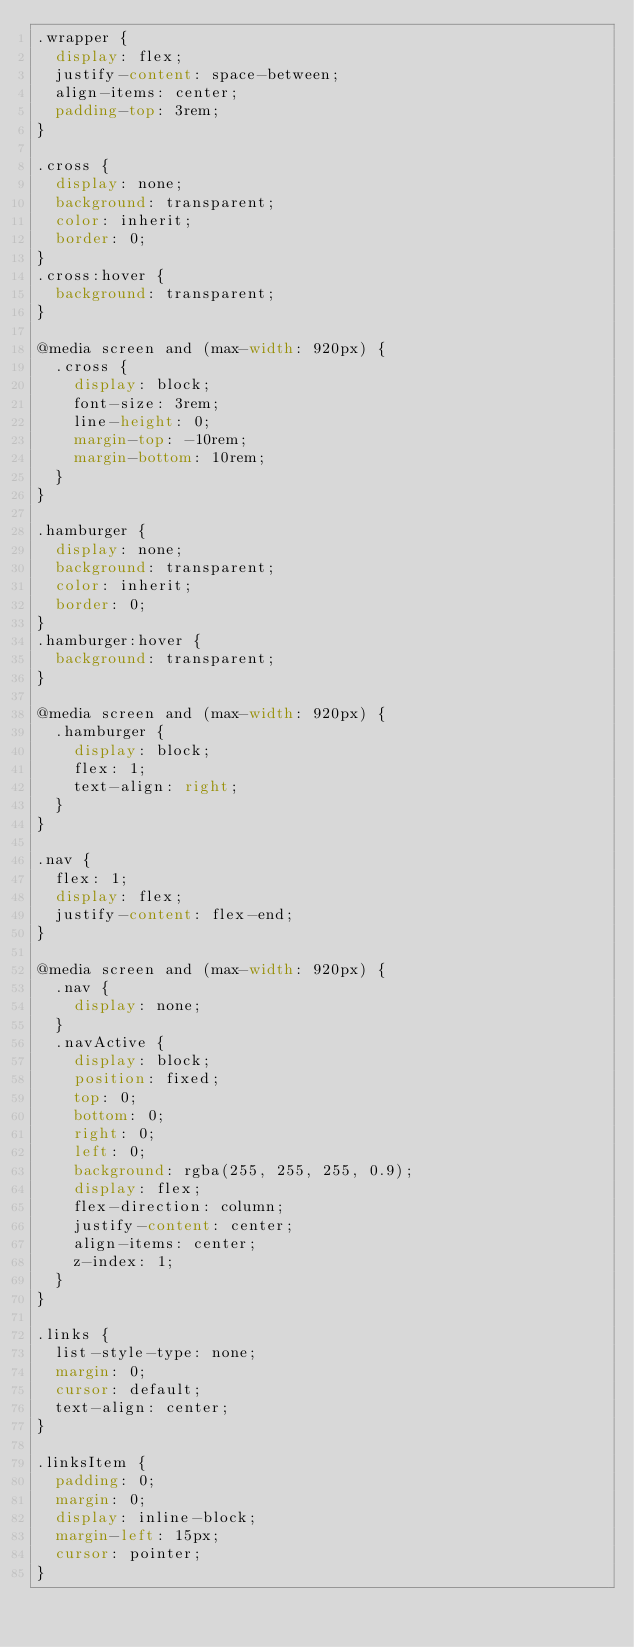Convert code to text. <code><loc_0><loc_0><loc_500><loc_500><_CSS_>.wrapper {
  display: flex;
  justify-content: space-between;
  align-items: center;
  padding-top: 3rem;
}

.cross {
  display: none;
  background: transparent;
  color: inherit;
  border: 0;
}
.cross:hover {
  background: transparent;
}

@media screen and (max-width: 920px) {
  .cross {
    display: block;
    font-size: 3rem;
    line-height: 0;
    margin-top: -10rem;
    margin-bottom: 10rem;
  }
}

.hamburger {
  display: none;
  background: transparent;
  color: inherit;
  border: 0;
}
.hamburger:hover {
  background: transparent;
}

@media screen and (max-width: 920px) {
  .hamburger {
    display: block;
    flex: 1;
    text-align: right;
  }
}

.nav {
  flex: 1;
  display: flex;
  justify-content: flex-end;
}

@media screen and (max-width: 920px) {
  .nav {
    display: none;
  }
  .navActive {
    display: block;
    position: fixed;
    top: 0;
    bottom: 0;
    right: 0;
    left: 0;
    background: rgba(255, 255, 255, 0.9);
    display: flex;
    flex-direction: column;
    justify-content: center;
    align-items: center;
    z-index: 1;
  }
}

.links {
  list-style-type: none;
  margin: 0;
  cursor: default;
  text-align: center;
}

.linksItem {
  padding: 0;
  margin: 0;
  display: inline-block;
  margin-left: 15px;
  cursor: pointer;
}
</code> 